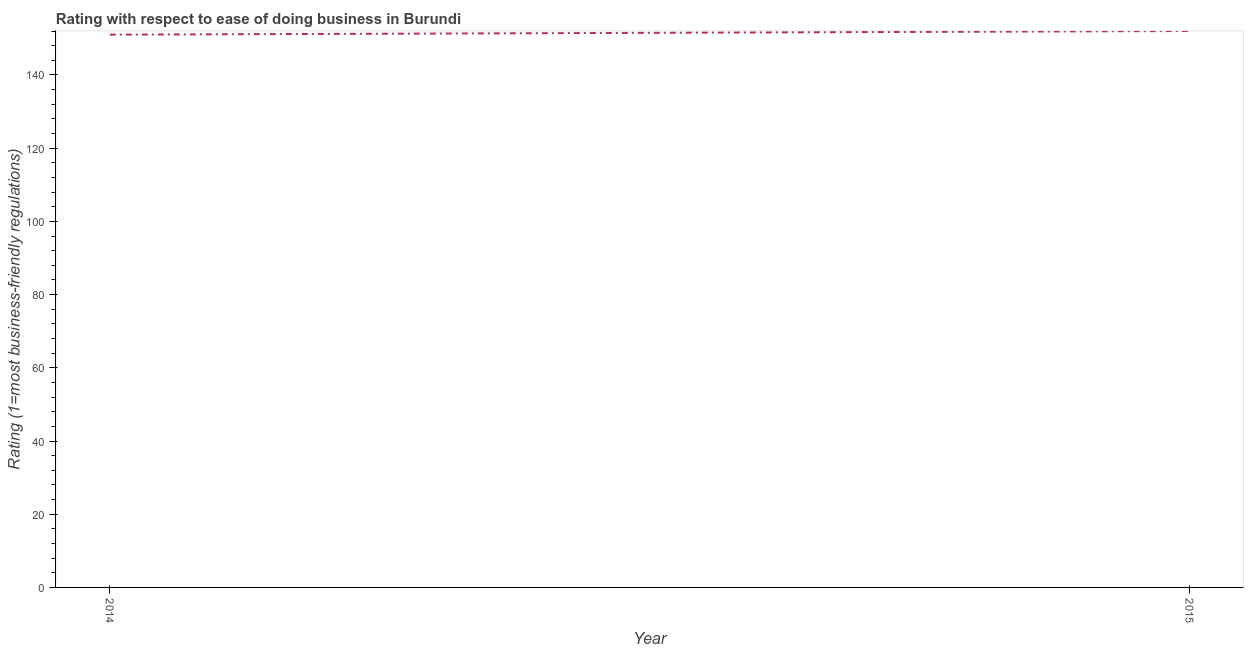What is the ease of doing business index in 2014?
Provide a short and direct response. 151. Across all years, what is the maximum ease of doing business index?
Your answer should be very brief. 152. Across all years, what is the minimum ease of doing business index?
Provide a succinct answer. 151. In which year was the ease of doing business index maximum?
Provide a short and direct response. 2015. In which year was the ease of doing business index minimum?
Provide a short and direct response. 2014. What is the sum of the ease of doing business index?
Your answer should be compact. 303. What is the difference between the ease of doing business index in 2014 and 2015?
Ensure brevity in your answer.  -1. What is the average ease of doing business index per year?
Provide a short and direct response. 151.5. What is the median ease of doing business index?
Your response must be concise. 151.5. What is the ratio of the ease of doing business index in 2014 to that in 2015?
Your answer should be very brief. 0.99. In how many years, is the ease of doing business index greater than the average ease of doing business index taken over all years?
Provide a short and direct response. 1. Does the ease of doing business index monotonically increase over the years?
Your answer should be very brief. Yes. Are the values on the major ticks of Y-axis written in scientific E-notation?
Keep it short and to the point. No. What is the title of the graph?
Ensure brevity in your answer.  Rating with respect to ease of doing business in Burundi. What is the label or title of the Y-axis?
Your answer should be very brief. Rating (1=most business-friendly regulations). What is the Rating (1=most business-friendly regulations) of 2014?
Ensure brevity in your answer.  151. What is the Rating (1=most business-friendly regulations) of 2015?
Ensure brevity in your answer.  152. What is the ratio of the Rating (1=most business-friendly regulations) in 2014 to that in 2015?
Your response must be concise. 0.99. 